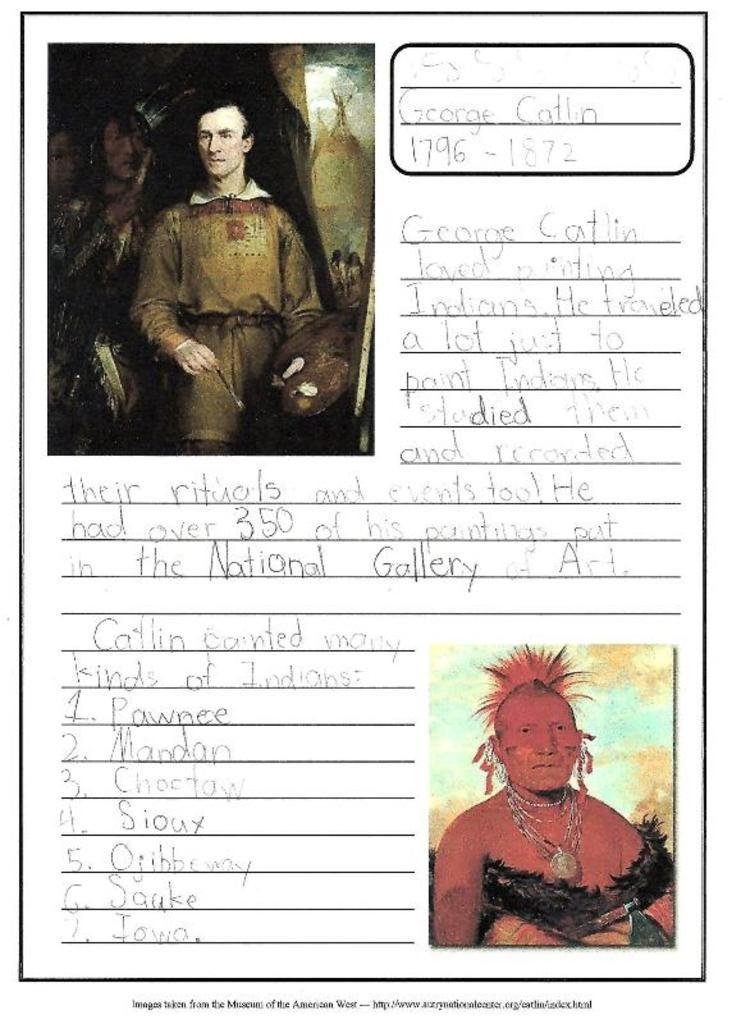What can be found on the page in the image? There are pictures and writing on the page. What do the pictures depict? The pictures depict ancient people. What type of information might be conveyed by the writing on the page? The writing on the page could provide details or context about the ancient people depicted in the pictures. How many matches are visible in the image? There are no matches present in the image. What type of arch can be seen in the image? There is no arch present in the image. 